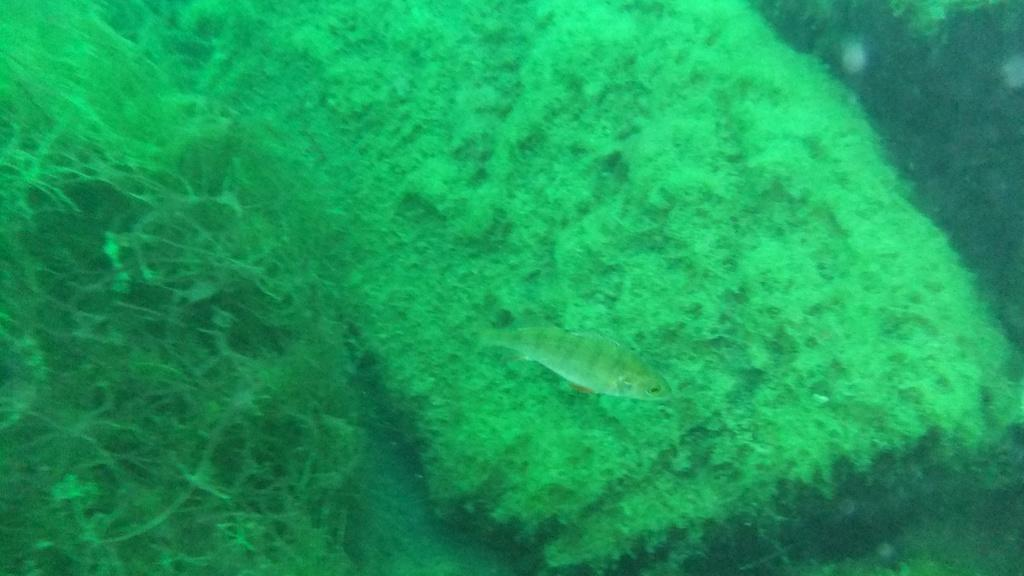Where was the image taken? The image is taken inside water. What can be seen in the center of the image? There is a fish in the center of the image. What type of vegetation is present in the background of the image? There is algae in the background of the image. What type of insurance policy is being discussed in the image? There is no discussion of insurance policies in the image; it features a fish inside water with algae in the background. 